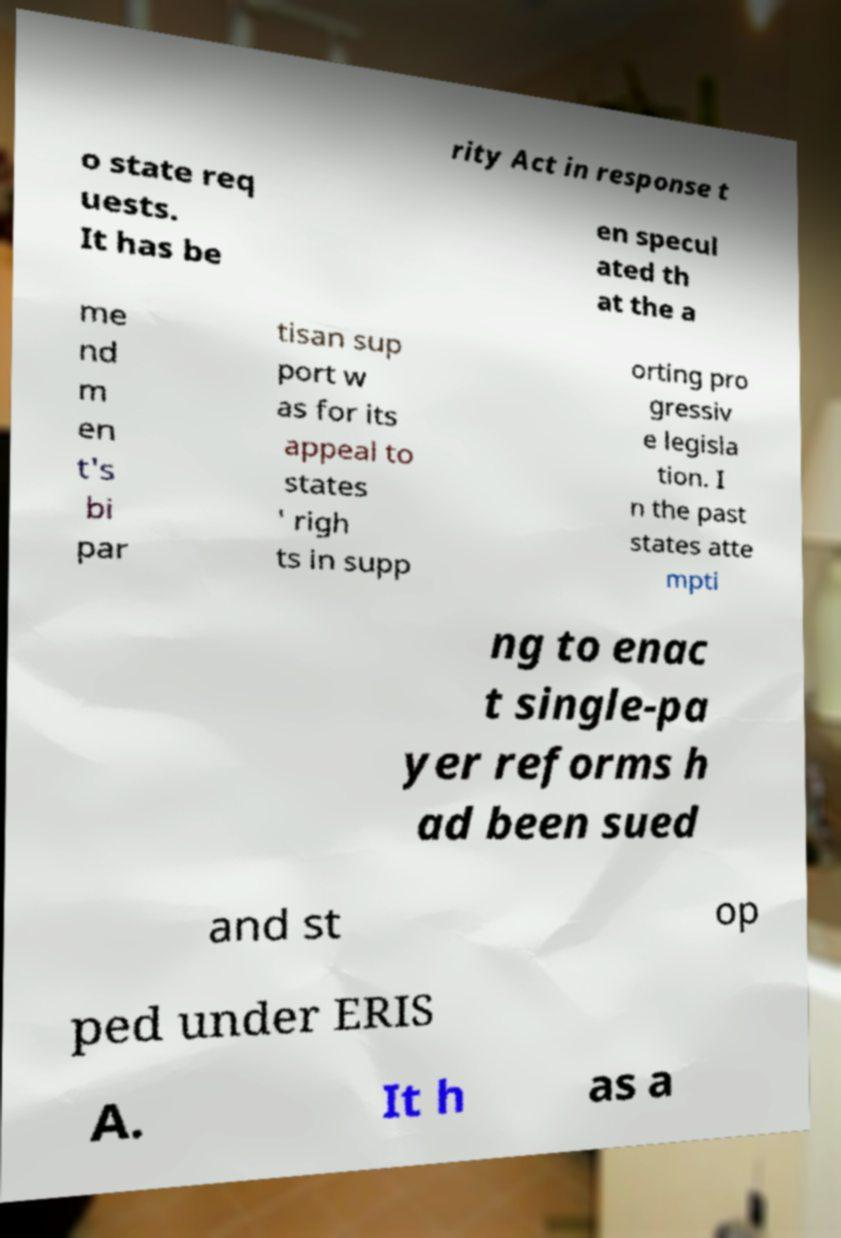For documentation purposes, I need the text within this image transcribed. Could you provide that? rity Act in response t o state req uests. It has be en specul ated th at the a me nd m en t's bi par tisan sup port w as for its appeal to states ' righ ts in supp orting pro gressiv e legisla tion. I n the past states atte mpti ng to enac t single-pa yer reforms h ad been sued and st op ped under ERIS A. It h as a 